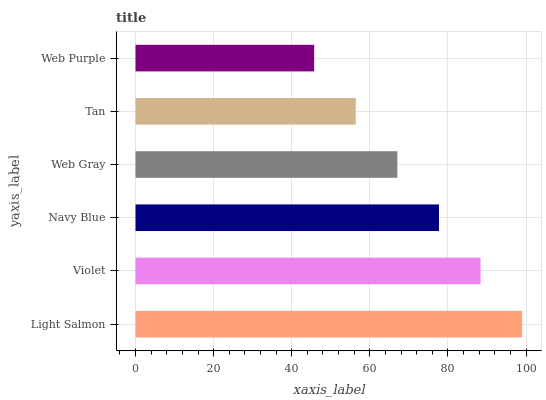Is Web Purple the minimum?
Answer yes or no. Yes. Is Light Salmon the maximum?
Answer yes or no. Yes. Is Violet the minimum?
Answer yes or no. No. Is Violet the maximum?
Answer yes or no. No. Is Light Salmon greater than Violet?
Answer yes or no. Yes. Is Violet less than Light Salmon?
Answer yes or no. Yes. Is Violet greater than Light Salmon?
Answer yes or no. No. Is Light Salmon less than Violet?
Answer yes or no. No. Is Navy Blue the high median?
Answer yes or no. Yes. Is Web Gray the low median?
Answer yes or no. Yes. Is Web Purple the high median?
Answer yes or no. No. Is Navy Blue the low median?
Answer yes or no. No. 